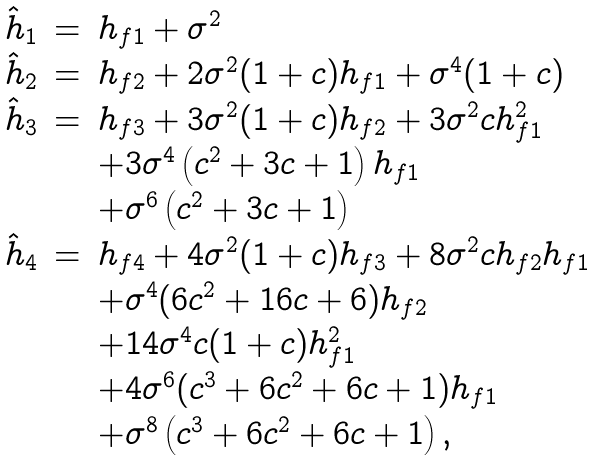Convert formula to latex. <formula><loc_0><loc_0><loc_500><loc_500>\begin{array} { l l l } \hat { h } _ { 1 } & = & h _ { f 1 } + \sigma ^ { 2 } \\ \hat { h } _ { 2 } & = & h _ { f 2 } + 2 { \sigma } ^ { 2 } ( 1 + c ) h _ { f 1 } + { \sigma } ^ { 4 } ( 1 + c ) \\ \hat { h } _ { 3 } & = & h _ { f 3 } + 3 { \sigma } ^ { 2 } ( 1 + c ) h _ { f 2 } + 3 { \sigma } ^ { 2 } c h _ { f 1 } ^ { 2 } \\ & & + 3 { \sigma } ^ { 4 } \left ( c ^ { 2 } + 3 c + 1 \right ) h _ { f 1 } \\ & & + { \sigma } ^ { 6 } \left ( c ^ { 2 } + 3 c + 1 \right ) \\ \hat { h } _ { 4 } & = & h _ { f 4 } + 4 { \sigma } ^ { 2 } ( 1 + c ) h _ { f 3 } + 8 { \sigma } ^ { 2 } c h _ { f 2 } h _ { f 1 } \\ & & + { \sigma } ^ { 4 } ( 6 c ^ { 2 } + 1 6 c + 6 ) h _ { f 2 } \\ & & + 1 4 { \sigma } ^ { 4 } c ( 1 + c ) h _ { f 1 } ^ { 2 } \\ & & + 4 { \sigma } ^ { 6 } ( c ^ { 3 } + 6 c ^ { 2 } + 6 c + 1 ) h _ { f 1 } \\ & & + { \sigma } ^ { 8 } \left ( c ^ { 3 } + 6 c ^ { 2 } + 6 c + 1 \right ) , \end{array}</formula> 